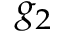Convert formula to latex. <formula><loc_0><loc_0><loc_500><loc_500>g _ { 2 }</formula> 